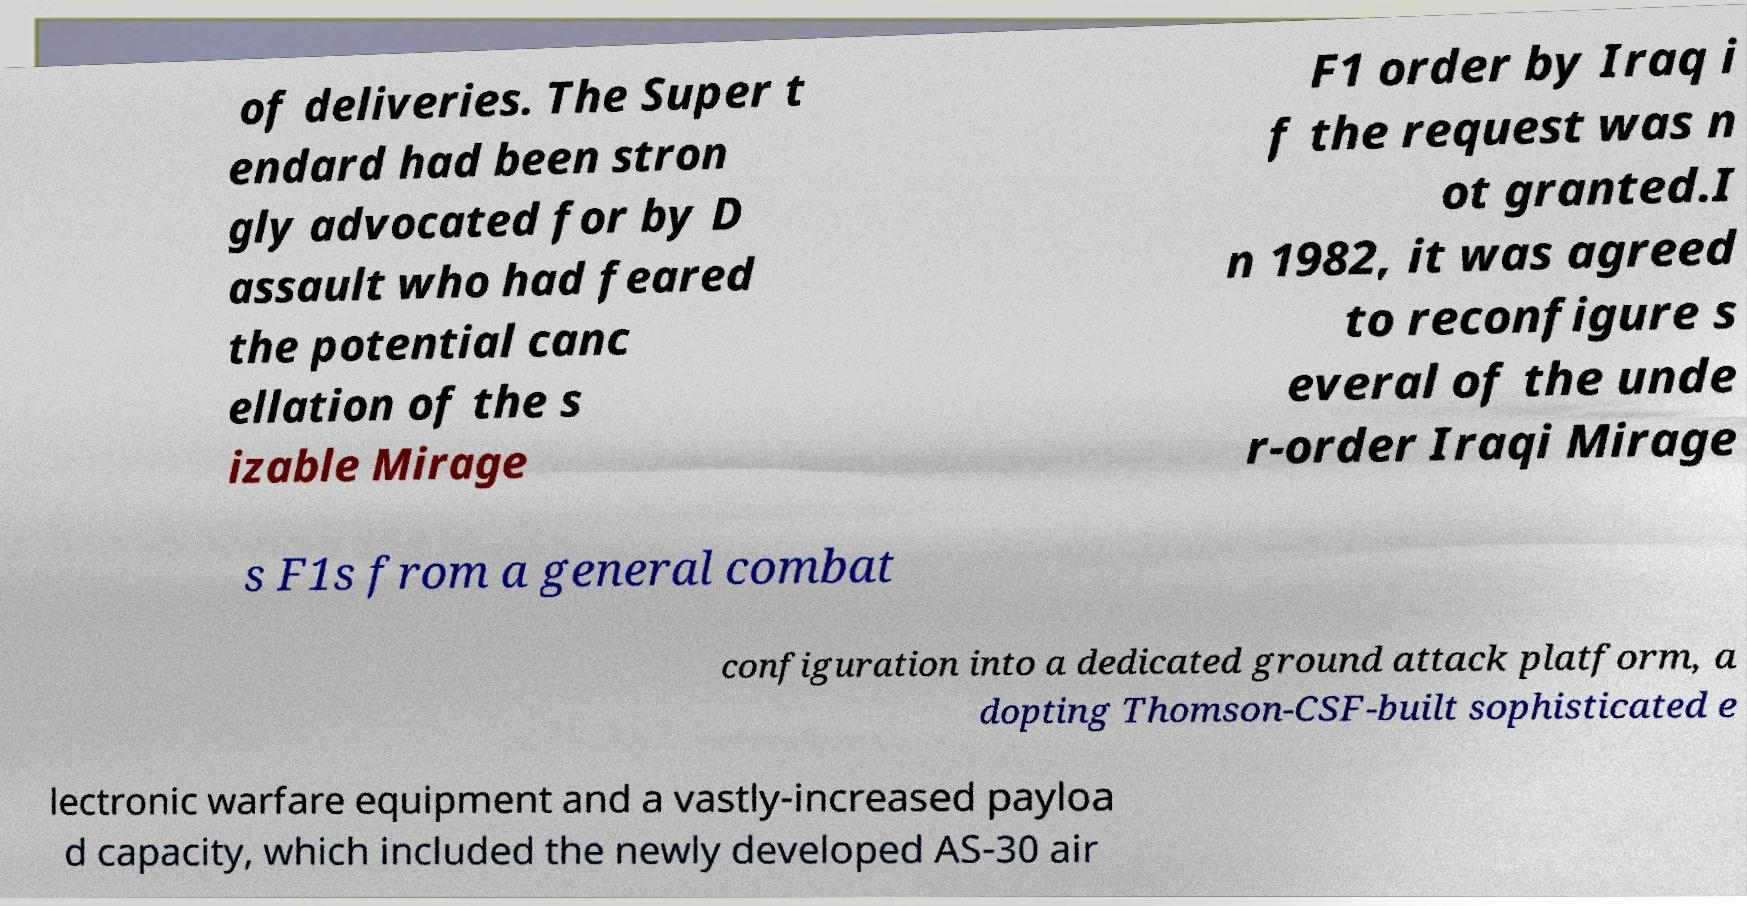I need the written content from this picture converted into text. Can you do that? of deliveries. The Super t endard had been stron gly advocated for by D assault who had feared the potential canc ellation of the s izable Mirage F1 order by Iraq i f the request was n ot granted.I n 1982, it was agreed to reconfigure s everal of the unde r-order Iraqi Mirage s F1s from a general combat configuration into a dedicated ground attack platform, a dopting Thomson-CSF-built sophisticated e lectronic warfare equipment and a vastly-increased payloa d capacity, which included the newly developed AS-30 air 